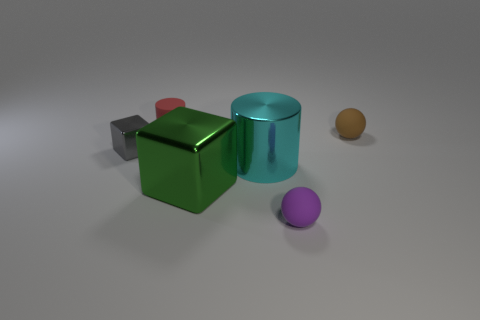Are there any tiny brown balls made of the same material as the small purple object?
Keep it short and to the point. Yes. Are the gray cube and the green cube made of the same material?
Provide a short and direct response. Yes. The rubber cylinder that is the same size as the gray metal cube is what color?
Offer a terse response. Red. What number of other things are the same shape as the green object?
Provide a succinct answer. 1. There is a purple rubber sphere; is it the same size as the rubber sphere behind the large green block?
Your answer should be compact. Yes. How many things are either tiny purple balls or tiny brown rubber balls?
Your response must be concise. 2. What number of other objects are the same size as the cyan cylinder?
Keep it short and to the point. 1. Do the large metallic cylinder and the tiny sphere behind the tiny purple ball have the same color?
Offer a terse response. No. How many spheres are either big objects or metal objects?
Give a very brief answer. 0. Is there anything else that is the same color as the small metal thing?
Make the answer very short. No. 